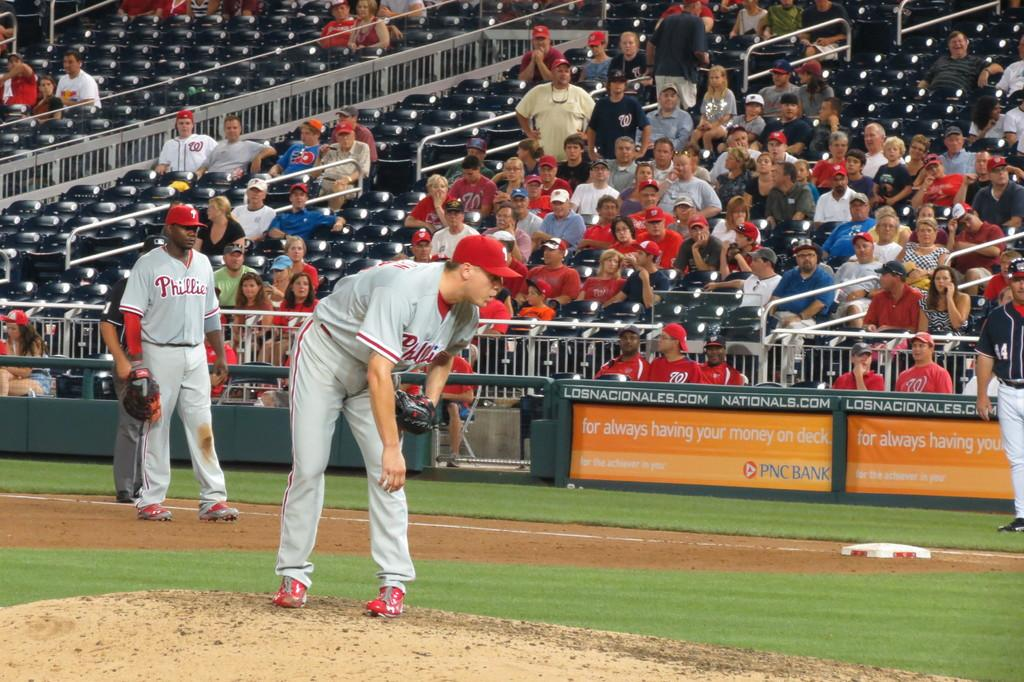<image>
Give a short and clear explanation of the subsequent image. The pitcher for the Phillies looks at the batter before delivering a pitch. 